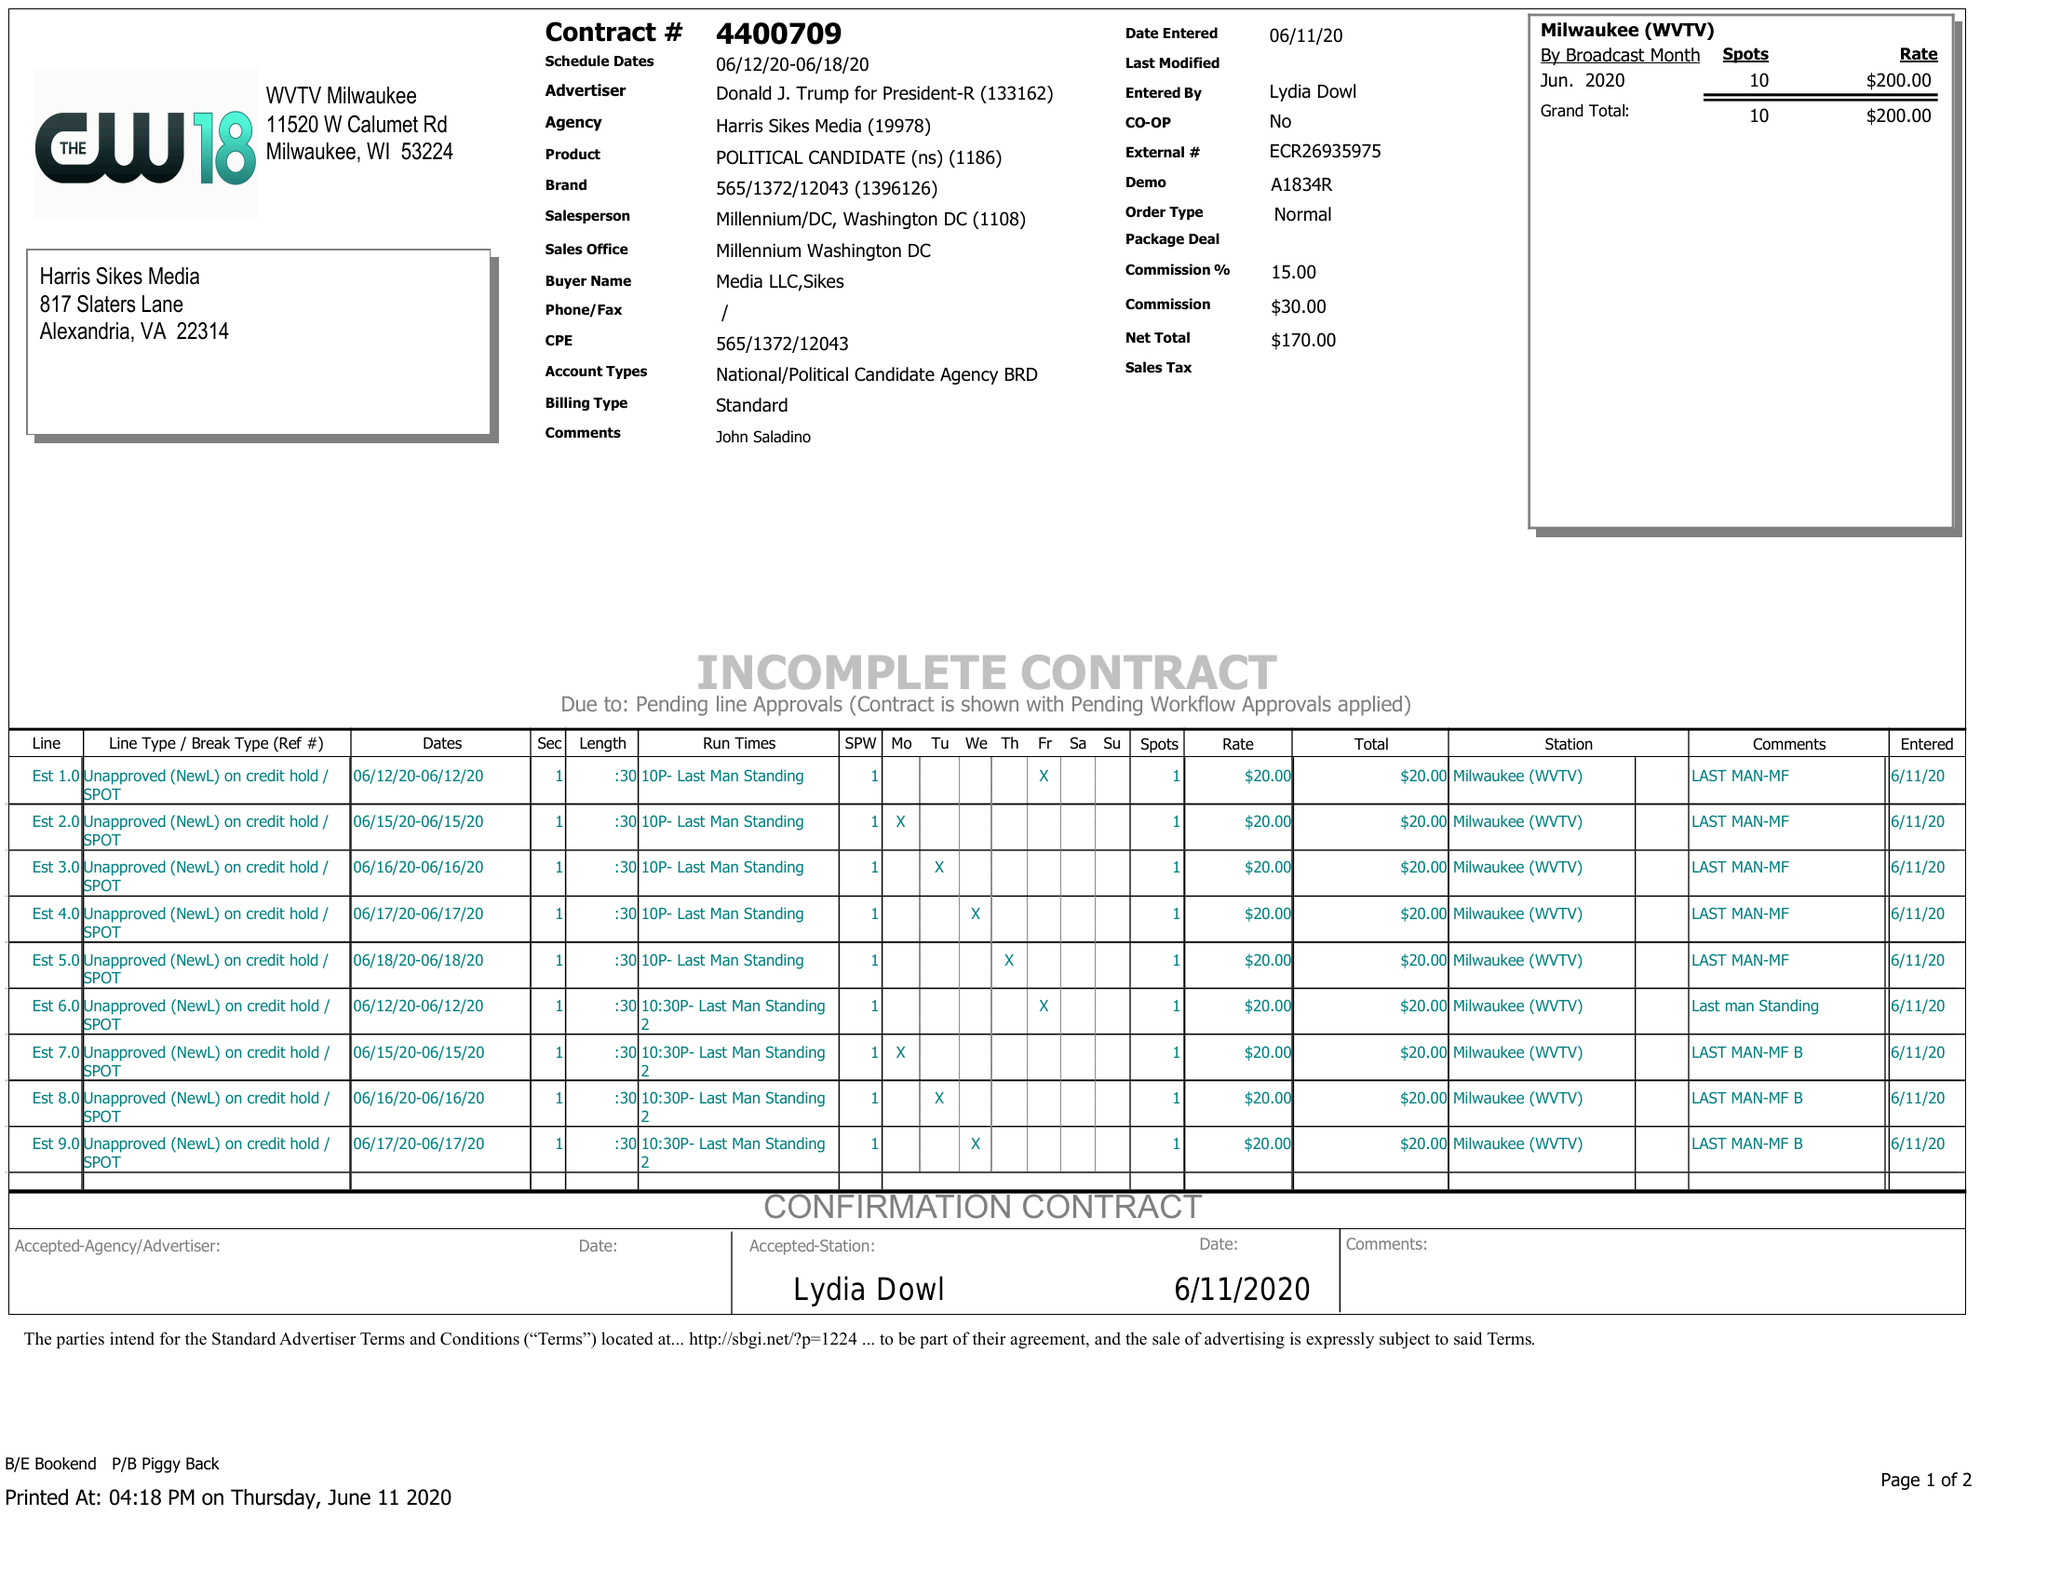What is the value for the contract_num?
Answer the question using a single word or phrase. 4400709 